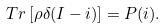Convert formula to latex. <formula><loc_0><loc_0><loc_500><loc_500>T r \left [ \rho \delta ( I - i ) \right ] = P ( i ) .</formula> 